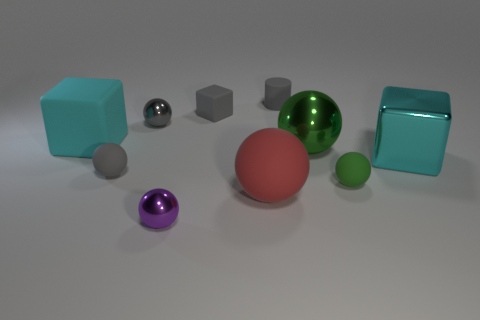Subtract 1 spheres. How many spheres are left? 5 Subtract all large cubes. How many cubes are left? 1 Subtract all purple balls. How many balls are left? 5 Subtract all purple spheres. Subtract all brown cylinders. How many spheres are left? 5 Subtract all blocks. How many objects are left? 7 Add 10 red metal objects. How many red metal objects exist? 10 Subtract 0 yellow balls. How many objects are left? 10 Subtract all matte objects. Subtract all tiny purple shiny balls. How many objects are left? 3 Add 1 large cyan shiny cubes. How many large cyan shiny cubes are left? 2 